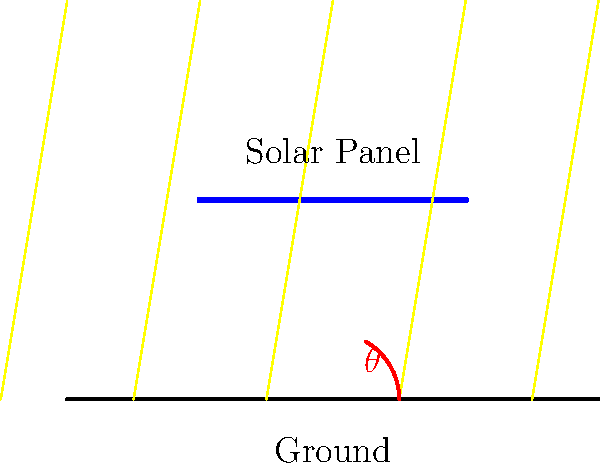As you take a break from your late-night writing session, you gaze out the window and notice a neighbor's solar panel installation. This sparks an idea for a scene in your novel involving renewable energy. You decide to calculate the power output of the solar panel to add authenticity to your writing. Given that the solar panel array has an area of 10 m², an efficiency of 20%, and receives solar radiation of 1000 W/m², what is the power output when the sun's rays make an angle $\theta = 60°$ with the horizontal ground as shown in the diagram? Let's approach this step-by-step:

1) First, we need to understand that the effective area of the solar panel depends on the angle of the sun's rays. The effective area is given by:

   $A_{effective} = A \cdot \cos(90°-\theta)$

   Where $A$ is the actual area of the panel, and $\theta$ is the angle between the sun's rays and the horizontal.

2) In this case, $\theta = 60°$, so:

   $A_{effective} = 10 \cdot \cos(90°-60°) = 10 \cdot \cos(30°) = 10 \cdot \frac{\sqrt{3}}{2} \approx 8.66$ m²

3) The power received by the panel is:

   $P_{received} = \text{Solar Radiation} \cdot A_{effective}$
   
   $P_{received} = 1000 \cdot 8.66 = 8660$ W

4) However, the panel is not 100% efficient. The actual power output is:

   $P_{output} = \text{Efficiency} \cdot P_{received}$
   
   $P_{output} = 0.20 \cdot 8660 = 1732$ W

Therefore, the power output of the solar panel array under these conditions is approximately 1732 W or 1.732 kW.
Answer: 1.732 kW 